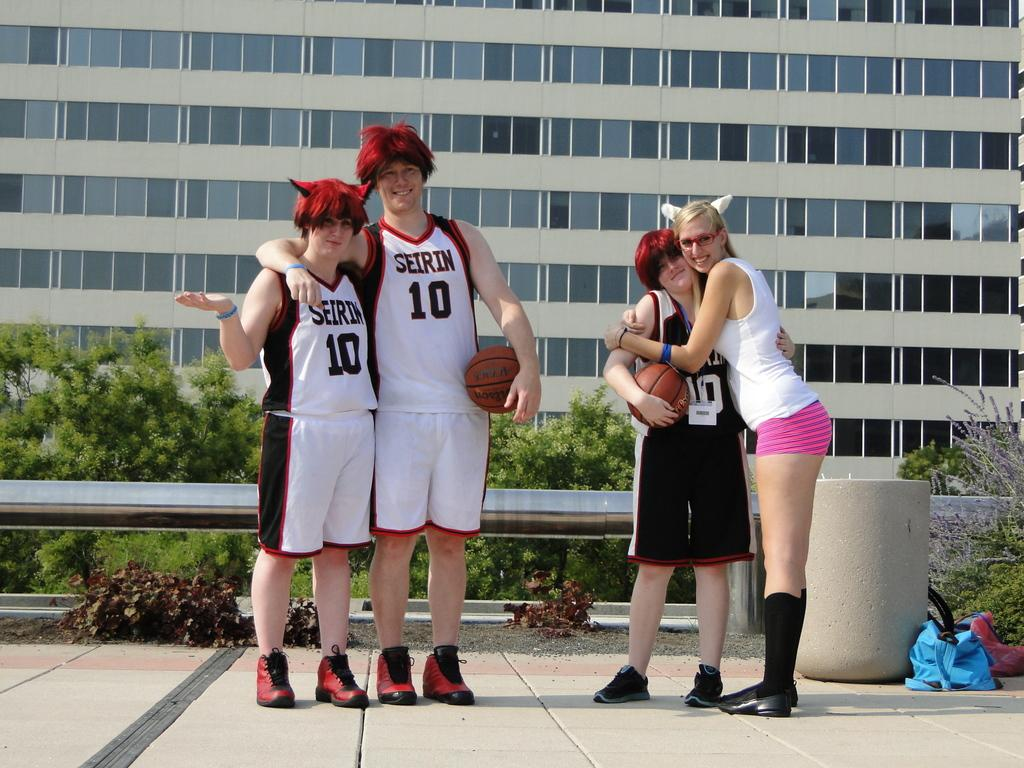<image>
Share a concise interpretation of the image provided. Three people wearing jerseys that have the number 10 on them stand with a woman wearing animal ears. 